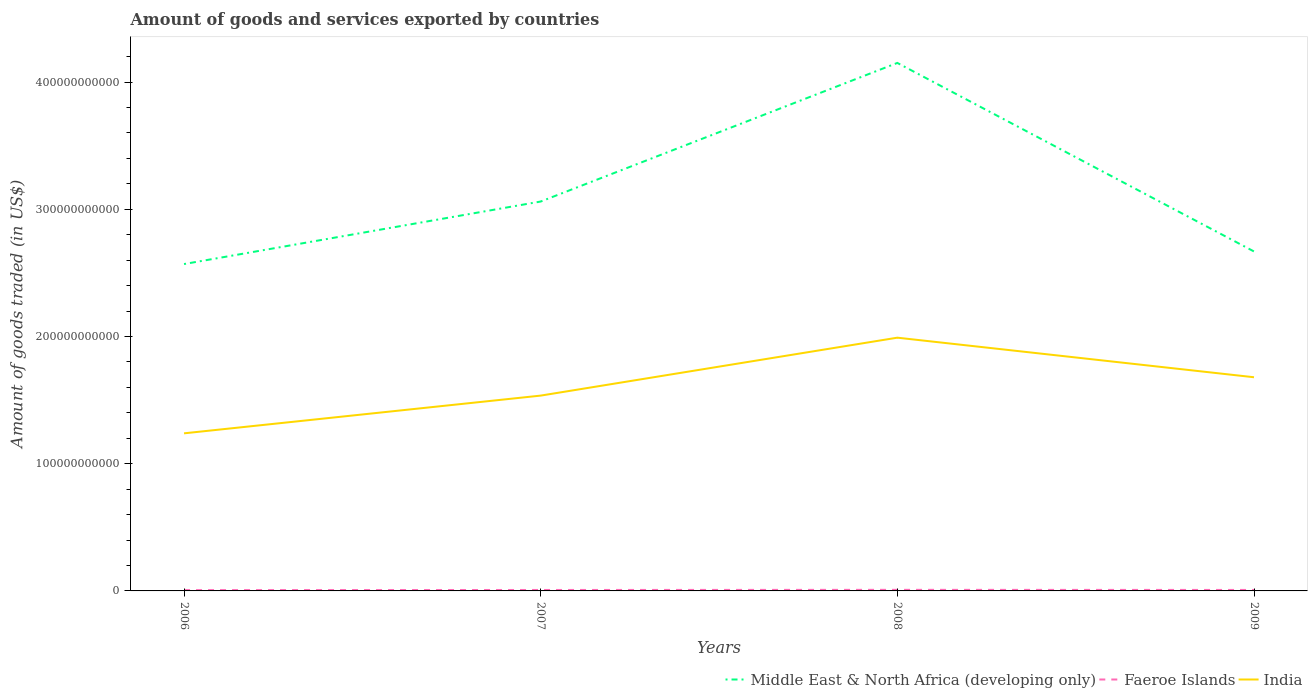How many different coloured lines are there?
Give a very brief answer. 3. Is the number of lines equal to the number of legend labels?
Offer a very short reply. Yes. Across all years, what is the maximum total amount of goods and services exported in India?
Offer a terse response. 1.24e+11. In which year was the total amount of goods and services exported in India maximum?
Keep it short and to the point. 2006. What is the total total amount of goods and services exported in Faeroe Islands in the graph?
Your response must be concise. -9.46e+07. What is the difference between the highest and the second highest total amount of goods and services exported in Middle East & North Africa (developing only)?
Give a very brief answer. 1.58e+11. What is the difference between the highest and the lowest total amount of goods and services exported in India?
Your answer should be compact. 2. Is the total amount of goods and services exported in India strictly greater than the total amount of goods and services exported in Faeroe Islands over the years?
Ensure brevity in your answer.  No. How many lines are there?
Keep it short and to the point. 3. How many years are there in the graph?
Your response must be concise. 4. What is the difference between two consecutive major ticks on the Y-axis?
Make the answer very short. 1.00e+11. Are the values on the major ticks of Y-axis written in scientific E-notation?
Provide a succinct answer. No. Where does the legend appear in the graph?
Offer a very short reply. Bottom right. How many legend labels are there?
Keep it short and to the point. 3. What is the title of the graph?
Offer a very short reply. Amount of goods and services exported by countries. What is the label or title of the X-axis?
Your response must be concise. Years. What is the label or title of the Y-axis?
Give a very brief answer. Amount of goods traded (in US$). What is the Amount of goods traded (in US$) of Middle East & North Africa (developing only) in 2006?
Offer a terse response. 2.57e+11. What is the Amount of goods traded (in US$) in Faeroe Islands in 2006?
Your answer should be compact. 6.51e+08. What is the Amount of goods traded (in US$) in India in 2006?
Your answer should be compact. 1.24e+11. What is the Amount of goods traded (in US$) in Middle East & North Africa (developing only) in 2007?
Your answer should be compact. 3.06e+11. What is the Amount of goods traded (in US$) of Faeroe Islands in 2007?
Provide a succinct answer. 7.45e+08. What is the Amount of goods traded (in US$) in India in 2007?
Keep it short and to the point. 1.54e+11. What is the Amount of goods traded (in US$) of Middle East & North Africa (developing only) in 2008?
Provide a succinct answer. 4.15e+11. What is the Amount of goods traded (in US$) of Faeroe Islands in 2008?
Offer a very short reply. 8.52e+08. What is the Amount of goods traded (in US$) of India in 2008?
Your response must be concise. 1.99e+11. What is the Amount of goods traded (in US$) in Middle East & North Africa (developing only) in 2009?
Give a very brief answer. 2.67e+11. What is the Amount of goods traded (in US$) of Faeroe Islands in 2009?
Provide a succinct answer. 7.66e+08. What is the Amount of goods traded (in US$) in India in 2009?
Give a very brief answer. 1.68e+11. Across all years, what is the maximum Amount of goods traded (in US$) of Middle East & North Africa (developing only)?
Offer a terse response. 4.15e+11. Across all years, what is the maximum Amount of goods traded (in US$) of Faeroe Islands?
Your answer should be compact. 8.52e+08. Across all years, what is the maximum Amount of goods traded (in US$) in India?
Provide a succinct answer. 1.99e+11. Across all years, what is the minimum Amount of goods traded (in US$) in Middle East & North Africa (developing only)?
Offer a terse response. 2.57e+11. Across all years, what is the minimum Amount of goods traded (in US$) of Faeroe Islands?
Provide a succinct answer. 6.51e+08. Across all years, what is the minimum Amount of goods traded (in US$) of India?
Offer a terse response. 1.24e+11. What is the total Amount of goods traded (in US$) in Middle East & North Africa (developing only) in the graph?
Offer a very short reply. 1.24e+12. What is the total Amount of goods traded (in US$) in Faeroe Islands in the graph?
Make the answer very short. 3.01e+09. What is the total Amount of goods traded (in US$) in India in the graph?
Offer a terse response. 6.44e+11. What is the difference between the Amount of goods traded (in US$) in Middle East & North Africa (developing only) in 2006 and that in 2007?
Your answer should be compact. -4.91e+1. What is the difference between the Amount of goods traded (in US$) in Faeroe Islands in 2006 and that in 2007?
Your response must be concise. -9.46e+07. What is the difference between the Amount of goods traded (in US$) of India in 2006 and that in 2007?
Give a very brief answer. -2.97e+1. What is the difference between the Amount of goods traded (in US$) in Middle East & North Africa (developing only) in 2006 and that in 2008?
Ensure brevity in your answer.  -1.58e+11. What is the difference between the Amount of goods traded (in US$) in Faeroe Islands in 2006 and that in 2008?
Ensure brevity in your answer.  -2.02e+08. What is the difference between the Amount of goods traded (in US$) of India in 2006 and that in 2008?
Your answer should be very brief. -7.52e+1. What is the difference between the Amount of goods traded (in US$) of Middle East & North Africa (developing only) in 2006 and that in 2009?
Make the answer very short. -9.88e+09. What is the difference between the Amount of goods traded (in US$) in Faeroe Islands in 2006 and that in 2009?
Keep it short and to the point. -1.15e+08. What is the difference between the Amount of goods traded (in US$) in India in 2006 and that in 2009?
Your answer should be compact. -4.41e+1. What is the difference between the Amount of goods traded (in US$) in Middle East & North Africa (developing only) in 2007 and that in 2008?
Offer a very short reply. -1.09e+11. What is the difference between the Amount of goods traded (in US$) in Faeroe Islands in 2007 and that in 2008?
Your response must be concise. -1.07e+08. What is the difference between the Amount of goods traded (in US$) in India in 2007 and that in 2008?
Provide a succinct answer. -4.55e+1. What is the difference between the Amount of goods traded (in US$) of Middle East & North Africa (developing only) in 2007 and that in 2009?
Provide a succinct answer. 3.93e+1. What is the difference between the Amount of goods traded (in US$) of Faeroe Islands in 2007 and that in 2009?
Make the answer very short. -2.05e+07. What is the difference between the Amount of goods traded (in US$) of India in 2007 and that in 2009?
Keep it short and to the point. -1.44e+1. What is the difference between the Amount of goods traded (in US$) in Middle East & North Africa (developing only) in 2008 and that in 2009?
Ensure brevity in your answer.  1.48e+11. What is the difference between the Amount of goods traded (in US$) in Faeroe Islands in 2008 and that in 2009?
Your answer should be compact. 8.67e+07. What is the difference between the Amount of goods traded (in US$) in India in 2008 and that in 2009?
Ensure brevity in your answer.  3.11e+1. What is the difference between the Amount of goods traded (in US$) in Middle East & North Africa (developing only) in 2006 and the Amount of goods traded (in US$) in Faeroe Islands in 2007?
Your answer should be compact. 2.56e+11. What is the difference between the Amount of goods traded (in US$) of Middle East & North Africa (developing only) in 2006 and the Amount of goods traded (in US$) of India in 2007?
Your response must be concise. 1.03e+11. What is the difference between the Amount of goods traded (in US$) in Faeroe Islands in 2006 and the Amount of goods traded (in US$) in India in 2007?
Keep it short and to the point. -1.53e+11. What is the difference between the Amount of goods traded (in US$) of Middle East & North Africa (developing only) in 2006 and the Amount of goods traded (in US$) of Faeroe Islands in 2008?
Your answer should be compact. 2.56e+11. What is the difference between the Amount of goods traded (in US$) in Middle East & North Africa (developing only) in 2006 and the Amount of goods traded (in US$) in India in 2008?
Your answer should be very brief. 5.79e+1. What is the difference between the Amount of goods traded (in US$) in Faeroe Islands in 2006 and the Amount of goods traded (in US$) in India in 2008?
Keep it short and to the point. -1.98e+11. What is the difference between the Amount of goods traded (in US$) of Middle East & North Africa (developing only) in 2006 and the Amount of goods traded (in US$) of Faeroe Islands in 2009?
Ensure brevity in your answer.  2.56e+11. What is the difference between the Amount of goods traded (in US$) of Middle East & North Africa (developing only) in 2006 and the Amount of goods traded (in US$) of India in 2009?
Give a very brief answer. 8.90e+1. What is the difference between the Amount of goods traded (in US$) of Faeroe Islands in 2006 and the Amount of goods traded (in US$) of India in 2009?
Your answer should be very brief. -1.67e+11. What is the difference between the Amount of goods traded (in US$) of Middle East & North Africa (developing only) in 2007 and the Amount of goods traded (in US$) of Faeroe Islands in 2008?
Make the answer very short. 3.05e+11. What is the difference between the Amount of goods traded (in US$) in Middle East & North Africa (developing only) in 2007 and the Amount of goods traded (in US$) in India in 2008?
Ensure brevity in your answer.  1.07e+11. What is the difference between the Amount of goods traded (in US$) of Faeroe Islands in 2007 and the Amount of goods traded (in US$) of India in 2008?
Offer a terse response. -1.98e+11. What is the difference between the Amount of goods traded (in US$) in Middle East & North Africa (developing only) in 2007 and the Amount of goods traded (in US$) in Faeroe Islands in 2009?
Your response must be concise. 3.05e+11. What is the difference between the Amount of goods traded (in US$) in Middle East & North Africa (developing only) in 2007 and the Amount of goods traded (in US$) in India in 2009?
Provide a short and direct response. 1.38e+11. What is the difference between the Amount of goods traded (in US$) in Faeroe Islands in 2007 and the Amount of goods traded (in US$) in India in 2009?
Provide a short and direct response. -1.67e+11. What is the difference between the Amount of goods traded (in US$) of Middle East & North Africa (developing only) in 2008 and the Amount of goods traded (in US$) of Faeroe Islands in 2009?
Your response must be concise. 4.14e+11. What is the difference between the Amount of goods traded (in US$) of Middle East & North Africa (developing only) in 2008 and the Amount of goods traded (in US$) of India in 2009?
Give a very brief answer. 2.47e+11. What is the difference between the Amount of goods traded (in US$) in Faeroe Islands in 2008 and the Amount of goods traded (in US$) in India in 2009?
Provide a short and direct response. -1.67e+11. What is the average Amount of goods traded (in US$) in Middle East & North Africa (developing only) per year?
Ensure brevity in your answer.  3.11e+11. What is the average Amount of goods traded (in US$) in Faeroe Islands per year?
Provide a succinct answer. 7.53e+08. What is the average Amount of goods traded (in US$) in India per year?
Keep it short and to the point. 1.61e+11. In the year 2006, what is the difference between the Amount of goods traded (in US$) in Middle East & North Africa (developing only) and Amount of goods traded (in US$) in Faeroe Islands?
Your answer should be compact. 2.56e+11. In the year 2006, what is the difference between the Amount of goods traded (in US$) in Middle East & North Africa (developing only) and Amount of goods traded (in US$) in India?
Offer a terse response. 1.33e+11. In the year 2006, what is the difference between the Amount of goods traded (in US$) in Faeroe Islands and Amount of goods traded (in US$) in India?
Offer a very short reply. -1.23e+11. In the year 2007, what is the difference between the Amount of goods traded (in US$) in Middle East & North Africa (developing only) and Amount of goods traded (in US$) in Faeroe Islands?
Make the answer very short. 3.05e+11. In the year 2007, what is the difference between the Amount of goods traded (in US$) of Middle East & North Africa (developing only) and Amount of goods traded (in US$) of India?
Offer a terse response. 1.53e+11. In the year 2007, what is the difference between the Amount of goods traded (in US$) in Faeroe Islands and Amount of goods traded (in US$) in India?
Your answer should be compact. -1.53e+11. In the year 2008, what is the difference between the Amount of goods traded (in US$) of Middle East & North Africa (developing only) and Amount of goods traded (in US$) of Faeroe Islands?
Keep it short and to the point. 4.14e+11. In the year 2008, what is the difference between the Amount of goods traded (in US$) in Middle East & North Africa (developing only) and Amount of goods traded (in US$) in India?
Ensure brevity in your answer.  2.16e+11. In the year 2008, what is the difference between the Amount of goods traded (in US$) of Faeroe Islands and Amount of goods traded (in US$) of India?
Offer a terse response. -1.98e+11. In the year 2009, what is the difference between the Amount of goods traded (in US$) in Middle East & North Africa (developing only) and Amount of goods traded (in US$) in Faeroe Islands?
Your answer should be compact. 2.66e+11. In the year 2009, what is the difference between the Amount of goods traded (in US$) in Middle East & North Africa (developing only) and Amount of goods traded (in US$) in India?
Ensure brevity in your answer.  9.89e+1. In the year 2009, what is the difference between the Amount of goods traded (in US$) in Faeroe Islands and Amount of goods traded (in US$) in India?
Give a very brief answer. -1.67e+11. What is the ratio of the Amount of goods traded (in US$) of Middle East & North Africa (developing only) in 2006 to that in 2007?
Provide a succinct answer. 0.84. What is the ratio of the Amount of goods traded (in US$) in Faeroe Islands in 2006 to that in 2007?
Provide a short and direct response. 0.87. What is the ratio of the Amount of goods traded (in US$) in India in 2006 to that in 2007?
Give a very brief answer. 0.81. What is the ratio of the Amount of goods traded (in US$) in Middle East & North Africa (developing only) in 2006 to that in 2008?
Provide a short and direct response. 0.62. What is the ratio of the Amount of goods traded (in US$) in Faeroe Islands in 2006 to that in 2008?
Your answer should be very brief. 0.76. What is the ratio of the Amount of goods traded (in US$) of India in 2006 to that in 2008?
Offer a terse response. 0.62. What is the ratio of the Amount of goods traded (in US$) in Middle East & North Africa (developing only) in 2006 to that in 2009?
Your response must be concise. 0.96. What is the ratio of the Amount of goods traded (in US$) in Faeroe Islands in 2006 to that in 2009?
Your response must be concise. 0.85. What is the ratio of the Amount of goods traded (in US$) in India in 2006 to that in 2009?
Provide a succinct answer. 0.74. What is the ratio of the Amount of goods traded (in US$) of Middle East & North Africa (developing only) in 2007 to that in 2008?
Your answer should be compact. 0.74. What is the ratio of the Amount of goods traded (in US$) of Faeroe Islands in 2007 to that in 2008?
Your answer should be very brief. 0.87. What is the ratio of the Amount of goods traded (in US$) in India in 2007 to that in 2008?
Keep it short and to the point. 0.77. What is the ratio of the Amount of goods traded (in US$) of Middle East & North Africa (developing only) in 2007 to that in 2009?
Your response must be concise. 1.15. What is the ratio of the Amount of goods traded (in US$) in Faeroe Islands in 2007 to that in 2009?
Offer a very short reply. 0.97. What is the ratio of the Amount of goods traded (in US$) of India in 2007 to that in 2009?
Your response must be concise. 0.91. What is the ratio of the Amount of goods traded (in US$) of Middle East & North Africa (developing only) in 2008 to that in 2009?
Keep it short and to the point. 1.56. What is the ratio of the Amount of goods traded (in US$) of Faeroe Islands in 2008 to that in 2009?
Give a very brief answer. 1.11. What is the ratio of the Amount of goods traded (in US$) in India in 2008 to that in 2009?
Ensure brevity in your answer.  1.19. What is the difference between the highest and the second highest Amount of goods traded (in US$) in Middle East & North Africa (developing only)?
Offer a very short reply. 1.09e+11. What is the difference between the highest and the second highest Amount of goods traded (in US$) in Faeroe Islands?
Provide a short and direct response. 8.67e+07. What is the difference between the highest and the second highest Amount of goods traded (in US$) in India?
Offer a terse response. 3.11e+1. What is the difference between the highest and the lowest Amount of goods traded (in US$) of Middle East & North Africa (developing only)?
Keep it short and to the point. 1.58e+11. What is the difference between the highest and the lowest Amount of goods traded (in US$) in Faeroe Islands?
Your answer should be very brief. 2.02e+08. What is the difference between the highest and the lowest Amount of goods traded (in US$) in India?
Your response must be concise. 7.52e+1. 